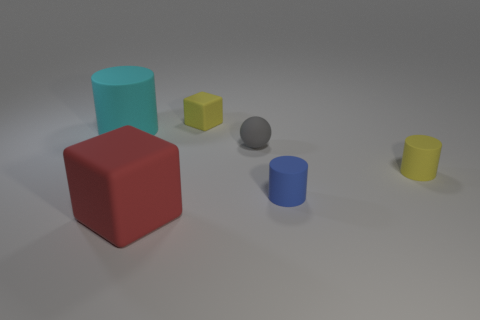Add 1 large red rubber objects. How many objects exist? 7 Subtract all blocks. How many objects are left? 4 Subtract all big cubes. Subtract all yellow rubber balls. How many objects are left? 5 Add 5 small rubber spheres. How many small rubber spheres are left? 6 Add 4 cyan matte things. How many cyan matte things exist? 5 Subtract 0 cyan blocks. How many objects are left? 6 